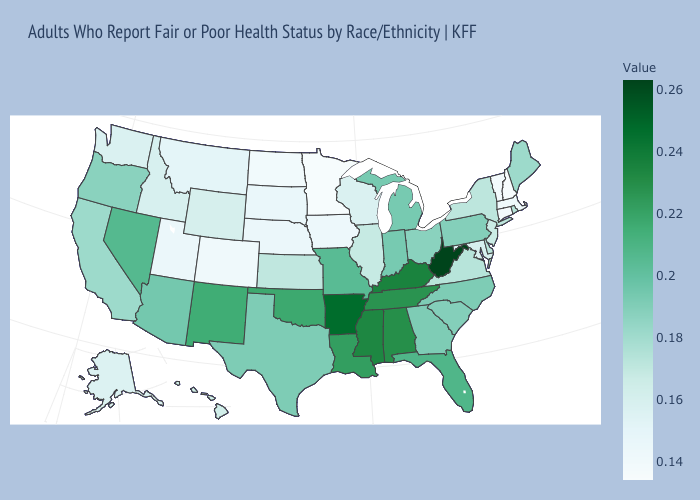Does the map have missing data?
Keep it brief. No. Which states have the highest value in the USA?
Be succinct. West Virginia. 